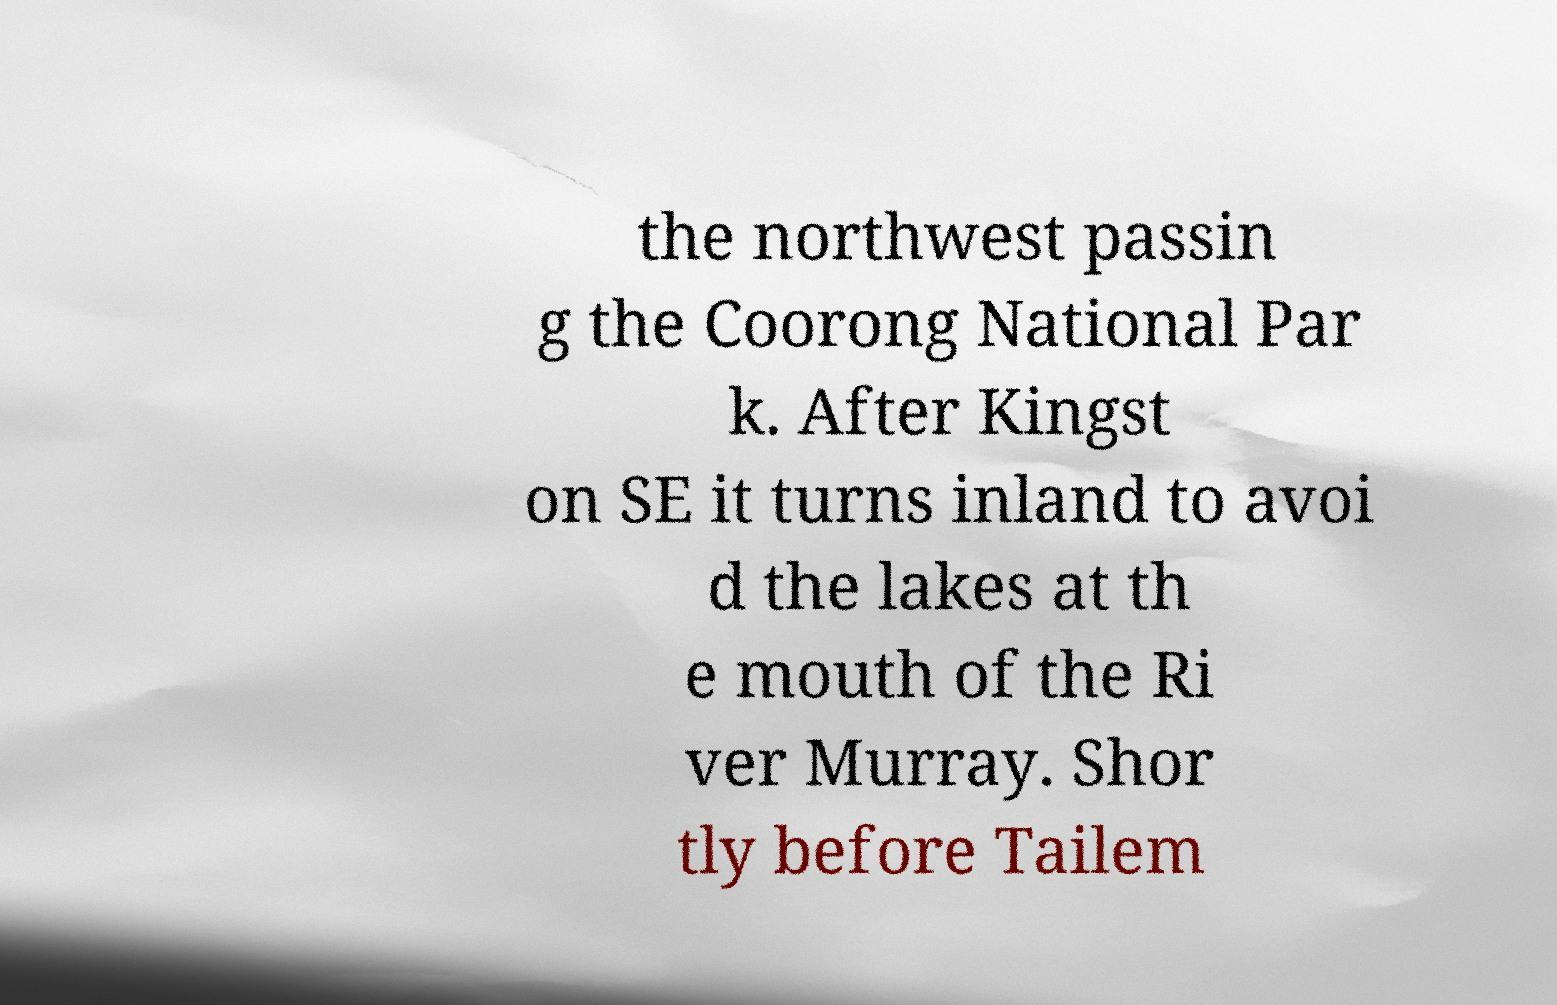Can you accurately transcribe the text from the provided image for me? the northwest passin g the Coorong National Par k. After Kingst on SE it turns inland to avoi d the lakes at th e mouth of the Ri ver Murray. Shor tly before Tailem 